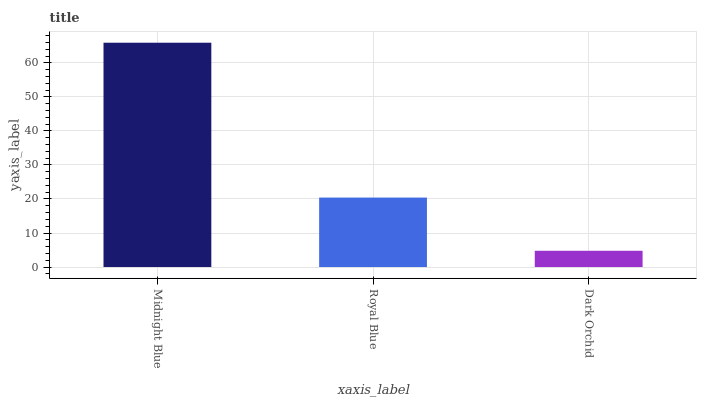Is Dark Orchid the minimum?
Answer yes or no. Yes. Is Midnight Blue the maximum?
Answer yes or no. Yes. Is Royal Blue the minimum?
Answer yes or no. No. Is Royal Blue the maximum?
Answer yes or no. No. Is Midnight Blue greater than Royal Blue?
Answer yes or no. Yes. Is Royal Blue less than Midnight Blue?
Answer yes or no. Yes. Is Royal Blue greater than Midnight Blue?
Answer yes or no. No. Is Midnight Blue less than Royal Blue?
Answer yes or no. No. Is Royal Blue the high median?
Answer yes or no. Yes. Is Royal Blue the low median?
Answer yes or no. Yes. Is Dark Orchid the high median?
Answer yes or no. No. Is Midnight Blue the low median?
Answer yes or no. No. 